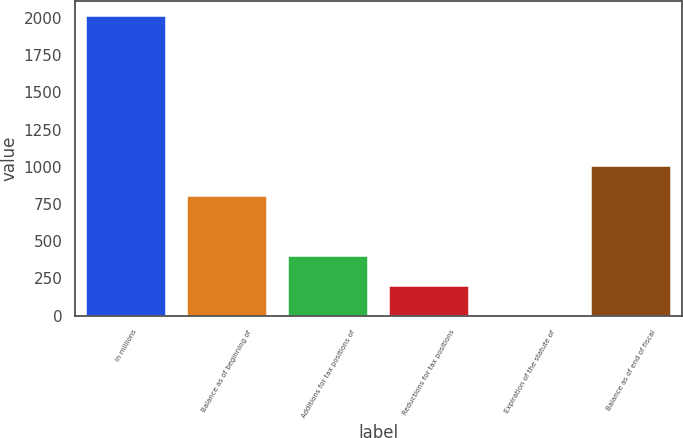Convert chart. <chart><loc_0><loc_0><loc_500><loc_500><bar_chart><fcel>In millions<fcel>Balance as of beginning of<fcel>Additions for tax positions of<fcel>Reductions for tax positions<fcel>Expiration of the statute of<fcel>Balance as of end of fiscal<nl><fcel>2014<fcel>805.78<fcel>403.04<fcel>201.67<fcel>0.3<fcel>1007.15<nl></chart> 